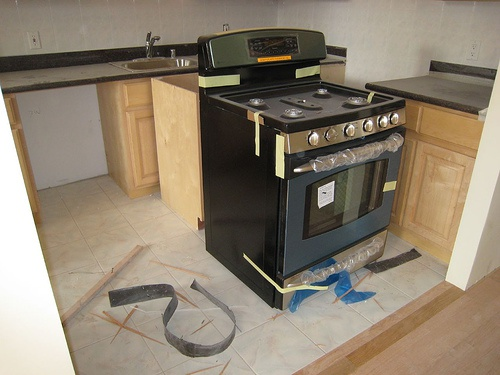Describe the objects in this image and their specific colors. I can see oven in gray, black, darkgreen, and purple tones and sink in gray, maroon, and black tones in this image. 